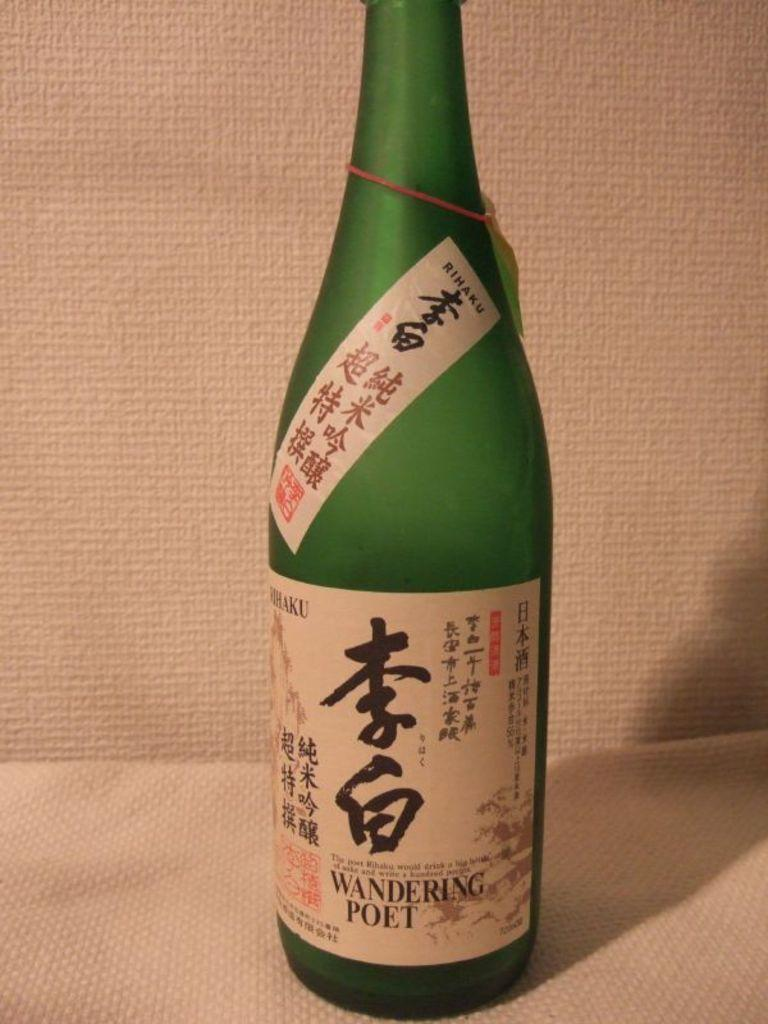<image>
Summarize the visual content of the image. A bottle of Wandering Poet contains Japanese writing on the label. 